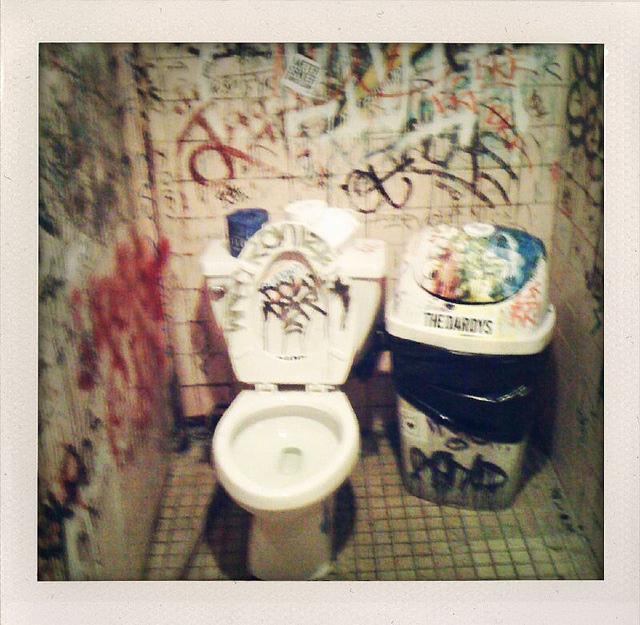What are the predominant colors of the graffiti here?
Answer briefly. Red and black. Are there marshmallows?
Be succinct. No. Is the garbage full?
Keep it brief. No. Is this bathroom sanitary?
Quick response, please. No. 